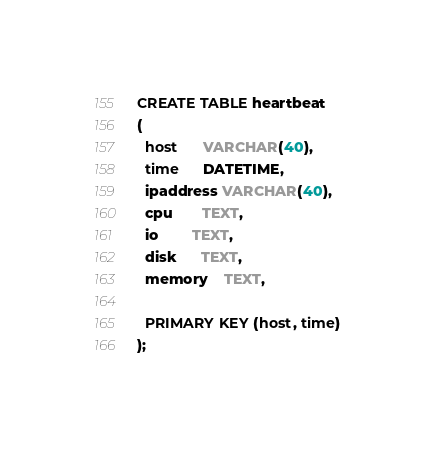<code> <loc_0><loc_0><loc_500><loc_500><_SQL_>CREATE TABLE heartbeat
(
  host      VARCHAR(40),
  time      DATETIME,
  ipaddress VARCHAR(40),
  cpu       TEXT,
  io        TEXT,
  disk      TEXT,
  memory    TEXT,
  
  PRIMARY KEY (host, time)
);
</code> 